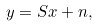<formula> <loc_0><loc_0><loc_500><loc_500>y = S x + n ,</formula> 